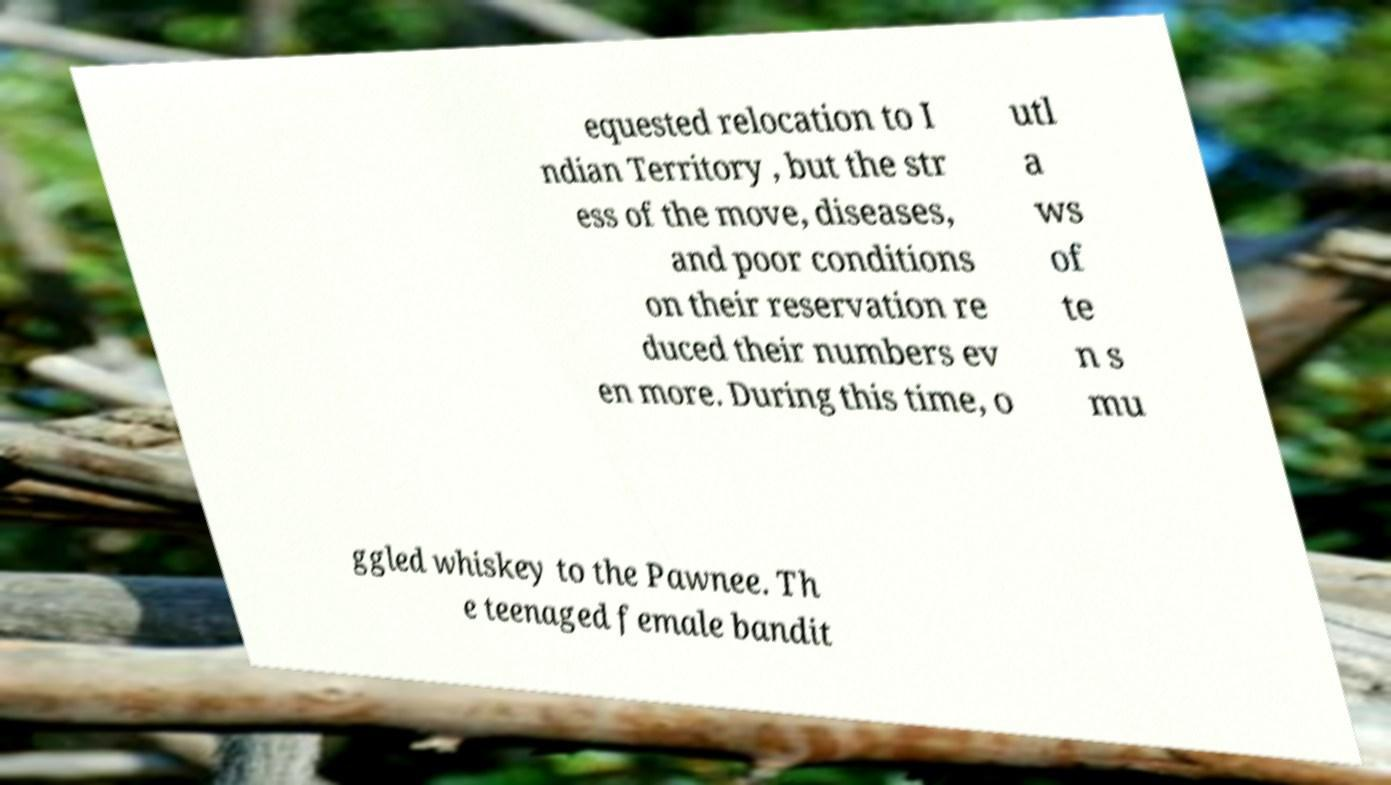Can you read and provide the text displayed in the image?This photo seems to have some interesting text. Can you extract and type it out for me? equested relocation to I ndian Territory , but the str ess of the move, diseases, and poor conditions on their reservation re duced their numbers ev en more. During this time, o utl a ws of te n s mu ggled whiskey to the Pawnee. Th e teenaged female bandit 